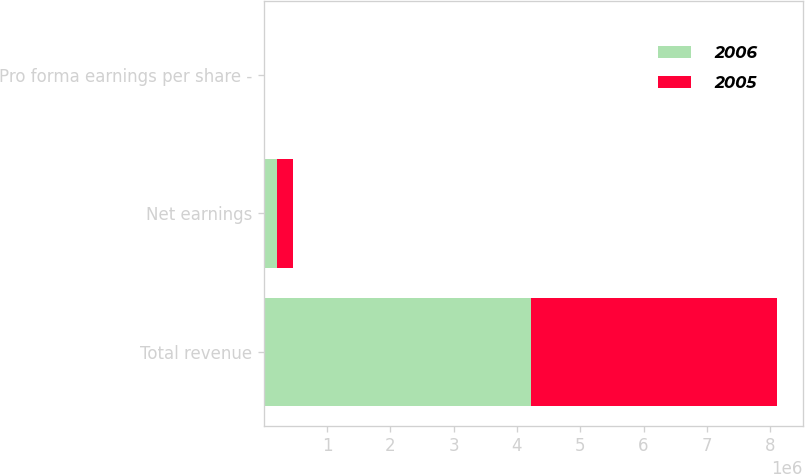Convert chart to OTSL. <chart><loc_0><loc_0><loc_500><loc_500><stacked_bar_chart><ecel><fcel>Total revenue<fcel>Net earnings<fcel>Pro forma earnings per share -<nl><fcel>2006<fcel>4.22552e+06<fcel>212856<fcel>1.09<nl><fcel>2005<fcel>3.88323e+06<fcel>249448<fcel>1.3<nl></chart> 